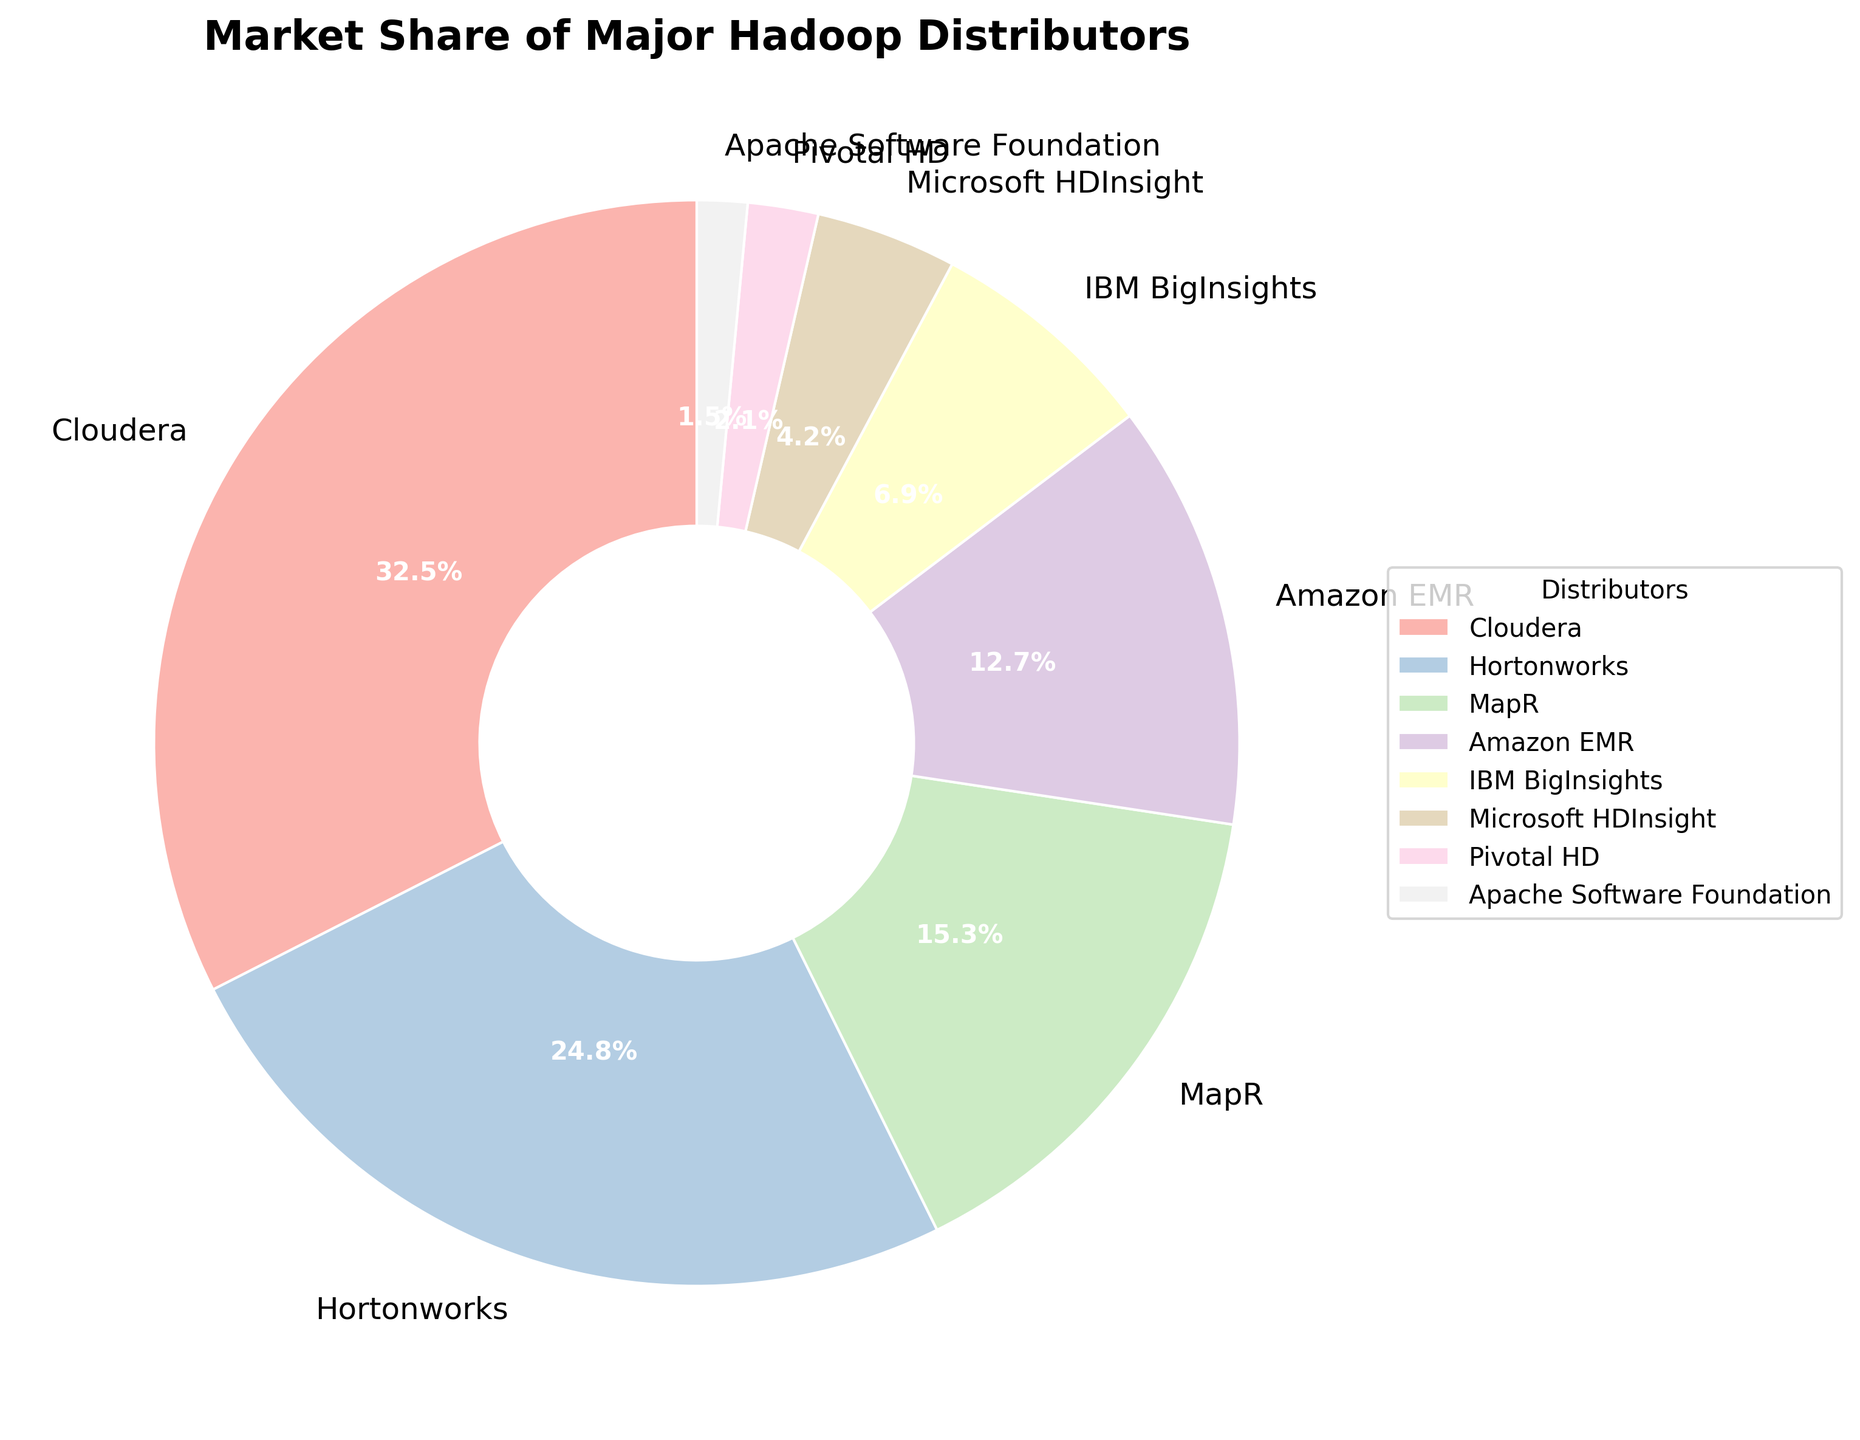What's the total market share of Cloudera and Hortonworks? To get the total market share of Cloudera and Hortonworks, add their market shares shown in the pie chart: Cloudera (32.5%) + Hortonworks (24.8%) = 57.3%.
Answer: 57.3% Which distributor has the smallest market share? From the pie chart, identify the distributor with the smallest wedge. Apache Software Foundation has the smallest segment, representing 1.5% of the market.
Answer: Apache Software Foundation Is the market share of Amazon EMR greater than or less than that of MapR? From the pie chart, Amazon EMR holds 12.7% and MapR holds 15.3%. Comparing these figures, Amazon EMR's share is smaller than MapR's.
Answer: Less than What is the color associated with IBM BigInsights in the pie chart? Referencing the visual attributes of the pie chart, IBM BigInsights segment is distinctly colored. According to the color palette used, it's a shade of pastel.
Answer: Shade of pastel (color exactness is visually based) How much more market share does Microsoft HDInsight need to reach a total of 10%? First, find the current share of Microsoft HDInsight which is 4.2%. Subtracting this from 10%, you get 10% - 4.2% = 5.8%.
Answer: 5.8% What's the combined market share of the three smallest distributors? Sum the market shares of the three smallest distributors: Microsoft HDInsight (4.2%) + Pivotal HD (2.1%) + Apache Software Foundation (1.5%) = 7.8%.
Answer: 7.8% Which distributor's market share is closest to one-quarter of the total pie? One-quarter of the pie equals 25%. Checking the chart, Hortonworks has a market share closest to this value with 24.8%.
Answer: Hortonworks How does the market share of Pivotal HD compare to that of Microsoft HDInsight? The pie chart shows Pivotal HD with 2.1% and Microsoft HDInsight with 4.2%. Comparing these values, Pivotal HD has a smaller share than Microsoft HDInsight.
Answer: Smaller If IBM BigInsights' market share doubled, which distributors would still have a larger share? Doubling IBM BigInsights' 6.9% gives 13.8%. Comparing 13.8% to other shares, Cloudera (32.5%), Hortonworks (24.8%), and MapR (15.3%) would still have larger shares.
Answer: Cloudera, Hortonworks, MapR Which distributors together make up more than 50% of the market share? Adding the shares of distributors from the largest: Cloudera (32.5%) + Hortonworks (24.8%) = 57.3%. These two alone make up more than 50%.
Answer: Cloudera and Hortonworks 